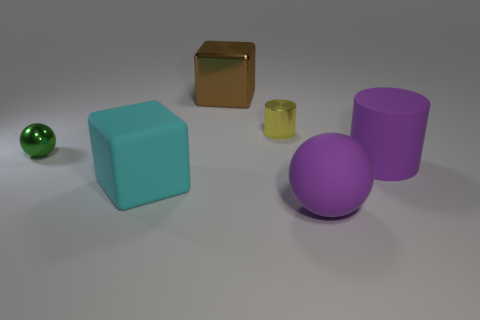Add 4 large red metal objects. How many objects exist? 10 Subtract all brown blocks. How many blocks are left? 1 Subtract all cubes. How many objects are left? 4 Subtract 0 green cylinders. How many objects are left? 6 Subtract all yellow cylinders. Subtract all cyan spheres. How many cylinders are left? 1 Subtract all tiny purple blocks. Subtract all big brown metallic blocks. How many objects are left? 5 Add 2 large rubber cylinders. How many large rubber cylinders are left? 3 Add 6 large things. How many large things exist? 10 